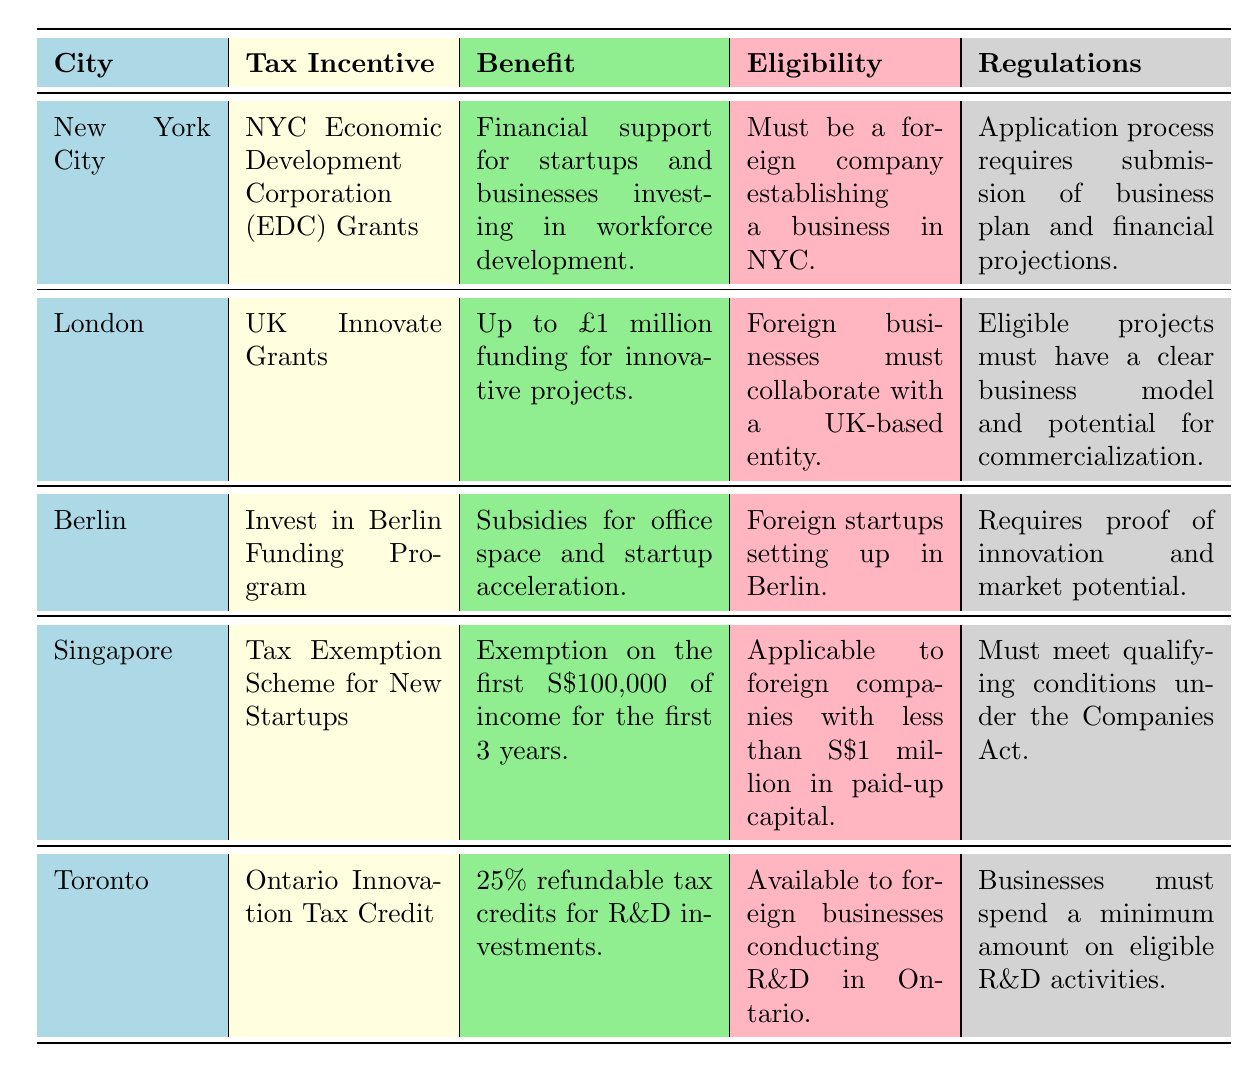What tax incentive is available for foreign businesses in New York City? The table indicates that the tax incentive available for foreign businesses in New York City is the NYC Economic Development Corporation (EDC) Grants.
Answer: NYC Economic Development Corporation (EDC) Grants What is the benefit provided by the UK Innovate Grants? According to the table, the benefit provided by the UK Innovate Grants is up to £1 million funding for innovative projects.
Answer: Up to £1 million funding for innovative projects Do foreign businesses in Berlin need to prove innovation? The table states that foreign startups in Berlin must provide proof of innovation and market potential as part of their regulations. Thus, the answer is yes.
Answer: Yes How many cities provide tax incentives that require collaboration with local entities? From the table, only London requires foreign businesses to collaborate with a UK-based entity. Therefore, there is one city with this requirement.
Answer: 1 What is the maximum exemption amount for the Tax Exemption Scheme for New Startups in Singapore? The table specifies that the Tax Exemption Scheme for New Startups offers an exemption on the first S$100,000 of income for the first three years, thus the maximum exemption amount is S$100,000.
Answer: S$100,000 What percentage of refundable tax credits does the Ontario Innovation Tax Credit provide? As per the table, the Ontario Innovation Tax Credit provides 25% refundable tax credits for R&D investments.
Answer: 25% Do all tax incentives listed in the table require submitting a business plan? The table indicates that only the NYC Economic Development Corporation (EDC) Grants mandate the submission of a business plan. Therefore, not all tax incentives require this.
Answer: No Which city has the most generous financial support mentioned in the table? Comparing the benefits listed, the UK Innovate Grants offer up to £1 million funding for innovative projects, which is the highest amount mentioned in the table.
Answer: London What are the eligibility criteria for the Tax Exemption Scheme for New Startups in Singapore? According to the table, the eligibility criteria specify that the scheme is applicable to foreign companies with less than S$1 million in paid-up capital.
Answer: Less than S$1 million in paid-up capital 